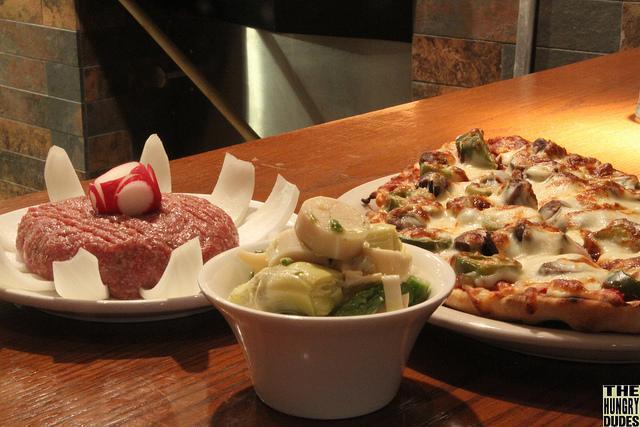What kind of meat is sat to the left of the pizza?
Select the accurate answer and provide justification: `Answer: choice
Rationale: srationale.`
Options: Chicken, roast, ground beef, duck. Answer: ground beef.
Rationale: Red, ground meat is in a bowl on a table. 